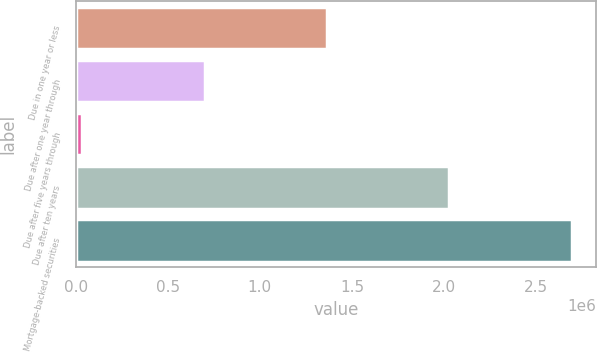<chart> <loc_0><loc_0><loc_500><loc_500><bar_chart><fcel>Due in one year or less<fcel>Due after one year through<fcel>Due after five years through<fcel>Due after ten years<fcel>Mortgage-backed securities<nl><fcel>1.36459e+06<fcel>700338<fcel>36083<fcel>2.02885e+06<fcel>2.6931e+06<nl></chart> 